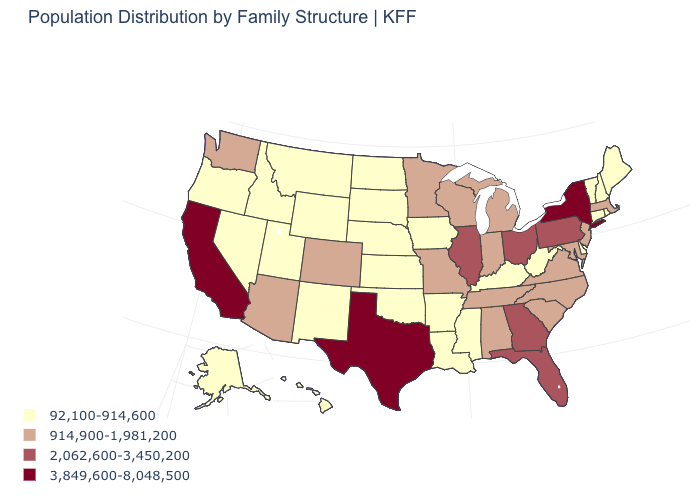Does Rhode Island have a higher value than California?
Answer briefly. No. Is the legend a continuous bar?
Short answer required. No. Is the legend a continuous bar?
Quick response, please. No. What is the lowest value in states that border Rhode Island?
Write a very short answer. 92,100-914,600. Which states have the lowest value in the MidWest?
Quick response, please. Iowa, Kansas, Nebraska, North Dakota, South Dakota. Among the states that border Maryland , does West Virginia have the lowest value?
Give a very brief answer. Yes. Does Maine have a lower value than North Carolina?
Quick response, please. Yes. What is the highest value in the Northeast ?
Be succinct. 3,849,600-8,048,500. Name the states that have a value in the range 3,849,600-8,048,500?
Concise answer only. California, New York, Texas. What is the value of Colorado?
Concise answer only. 914,900-1,981,200. Name the states that have a value in the range 3,849,600-8,048,500?
Answer briefly. California, New York, Texas. What is the value of Utah?
Be succinct. 92,100-914,600. What is the lowest value in the USA?
Give a very brief answer. 92,100-914,600. What is the lowest value in states that border Wisconsin?
Concise answer only. 92,100-914,600. 